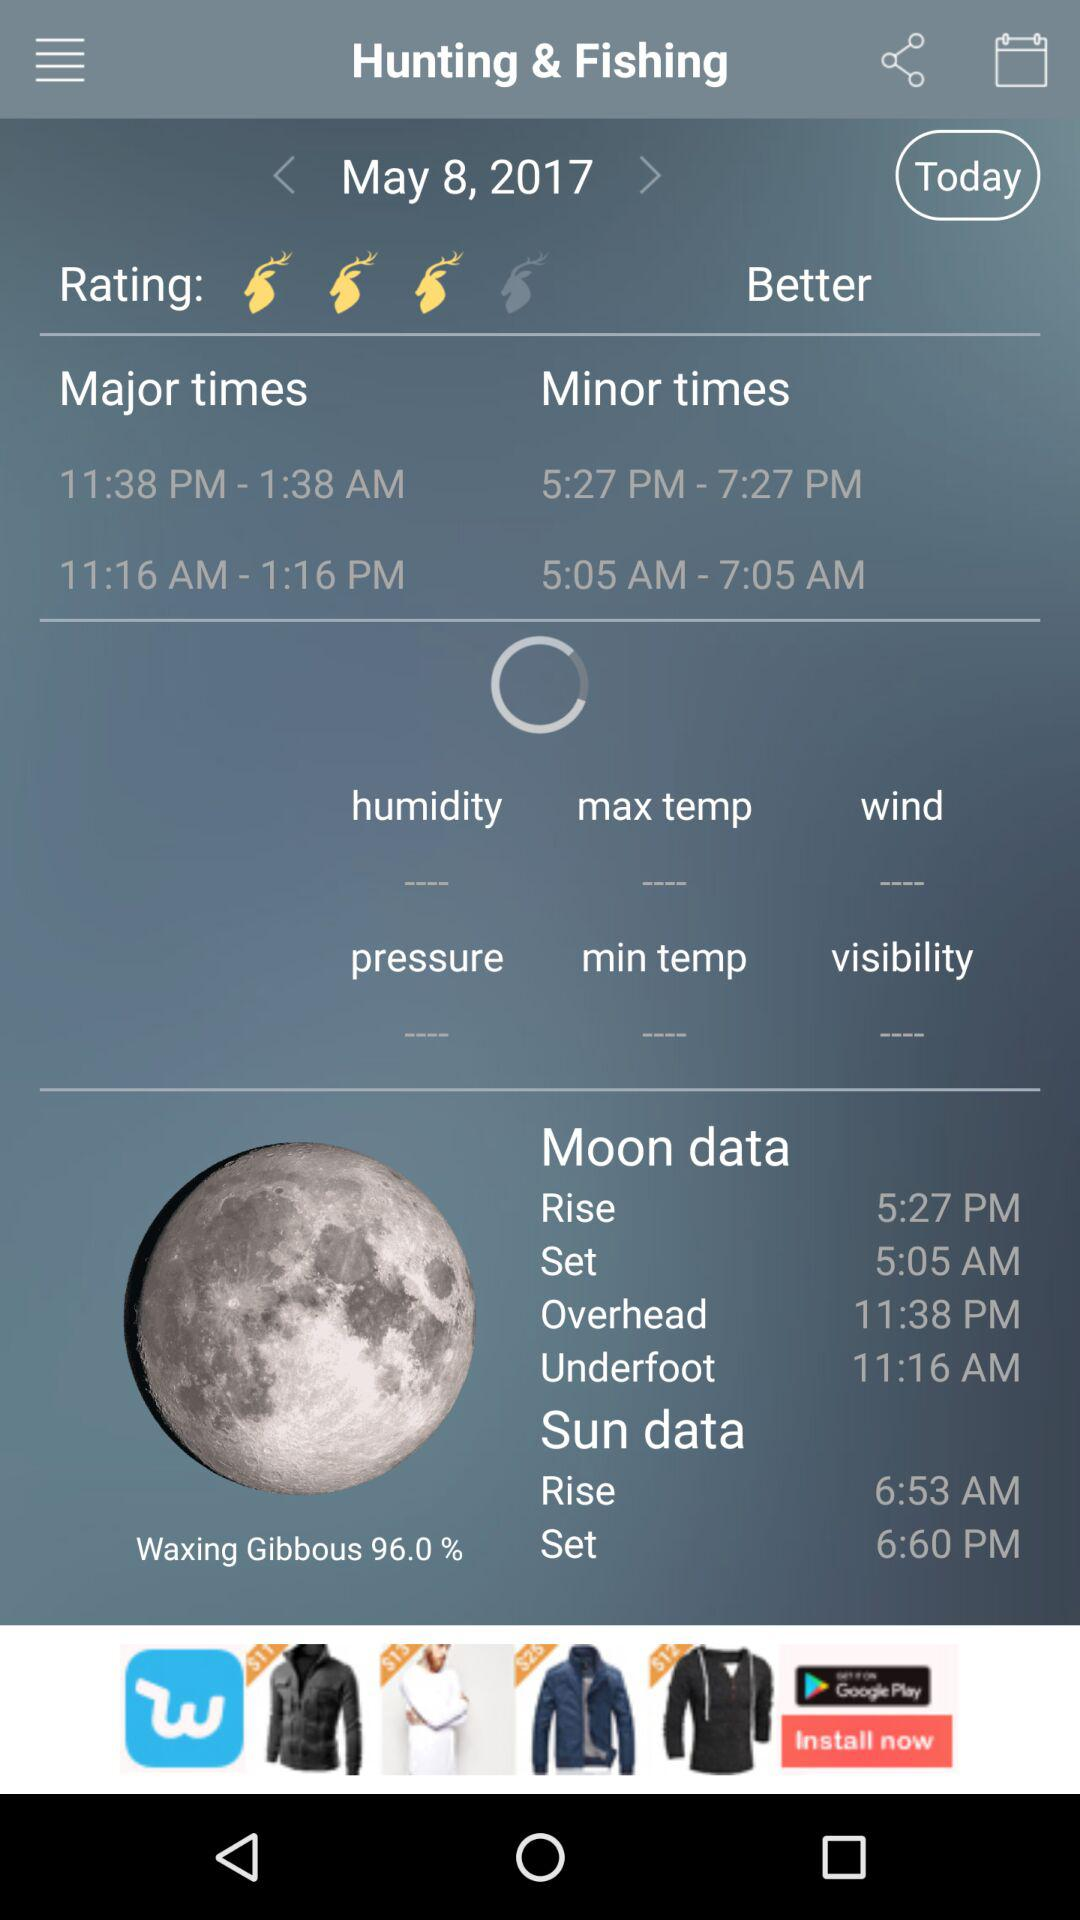What are the given major times? The times are 11:38 PM-1:38 AM, 11:16 AM-1:6 PM. 